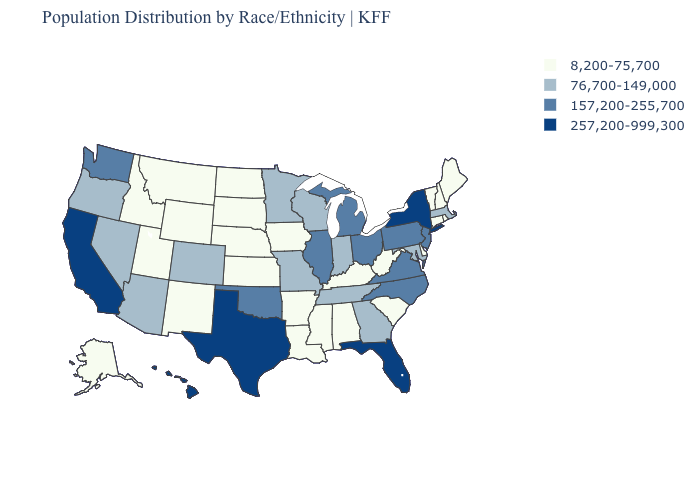Among the states that border Iowa , which have the lowest value?
Give a very brief answer. Nebraska, South Dakota. What is the value of Louisiana?
Answer briefly. 8,200-75,700. Name the states that have a value in the range 76,700-149,000?
Short answer required. Arizona, Colorado, Georgia, Indiana, Maryland, Massachusetts, Minnesota, Missouri, Nevada, Oregon, Tennessee, Wisconsin. Is the legend a continuous bar?
Answer briefly. No. What is the value of Connecticut?
Concise answer only. 8,200-75,700. Among the states that border Rhode Island , which have the lowest value?
Quick response, please. Connecticut. Name the states that have a value in the range 76,700-149,000?
Give a very brief answer. Arizona, Colorado, Georgia, Indiana, Maryland, Massachusetts, Minnesota, Missouri, Nevada, Oregon, Tennessee, Wisconsin. What is the value of Vermont?
Concise answer only. 8,200-75,700. What is the value of Wyoming?
Write a very short answer. 8,200-75,700. What is the highest value in the USA?
Quick response, please. 257,200-999,300. Among the states that border Indiana , which have the lowest value?
Answer briefly. Kentucky. Name the states that have a value in the range 257,200-999,300?
Quick response, please. California, Florida, Hawaii, New York, Texas. What is the highest value in states that border New Mexico?
Write a very short answer. 257,200-999,300. What is the highest value in the West ?
Be succinct. 257,200-999,300. What is the value of Vermont?
Short answer required. 8,200-75,700. 